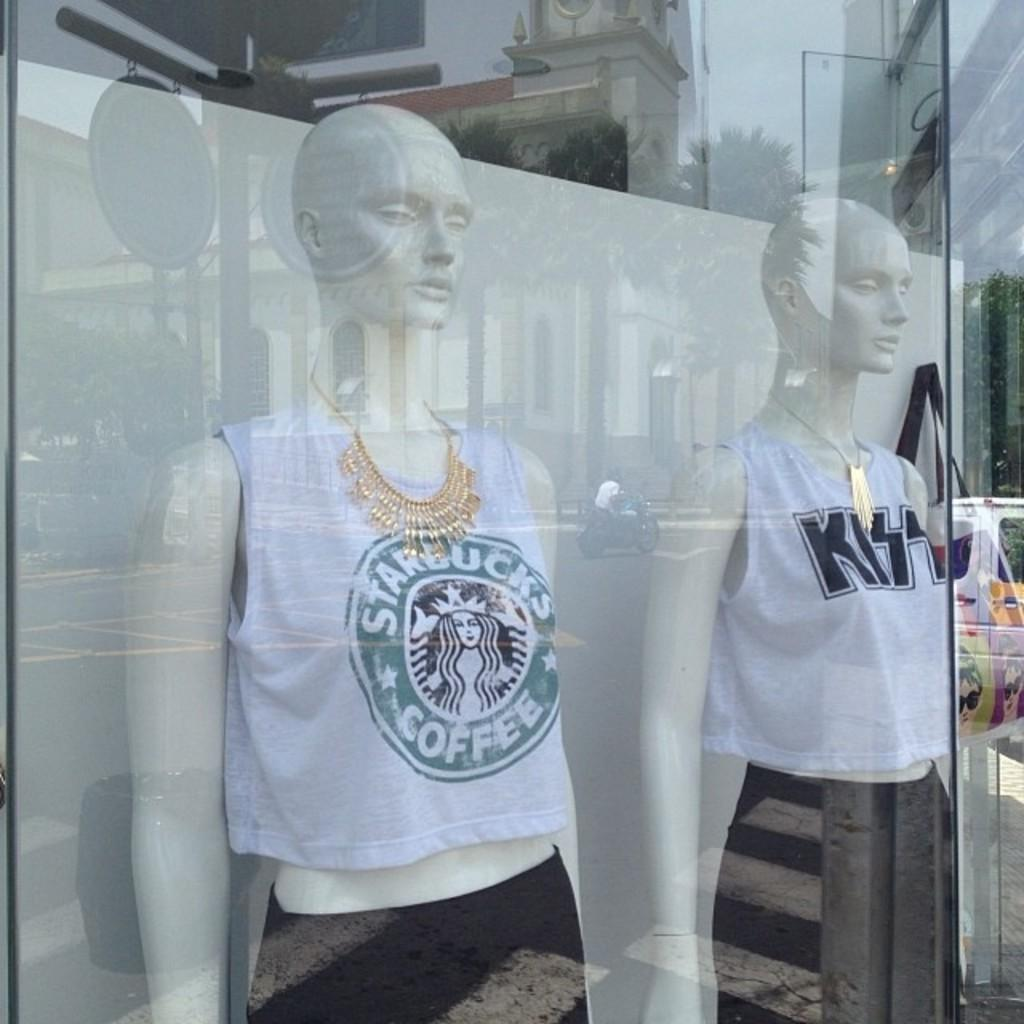<image>
Share a concise interpretation of the image provided. A mannequin in a window is wearing a Starbucks tank top. 